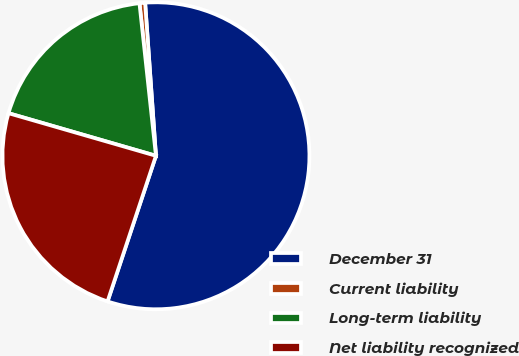<chart> <loc_0><loc_0><loc_500><loc_500><pie_chart><fcel>December 31<fcel>Current liability<fcel>Long-term liability<fcel>Net liability recognized<nl><fcel>56.23%<fcel>0.59%<fcel>18.81%<fcel>24.37%<nl></chart> 